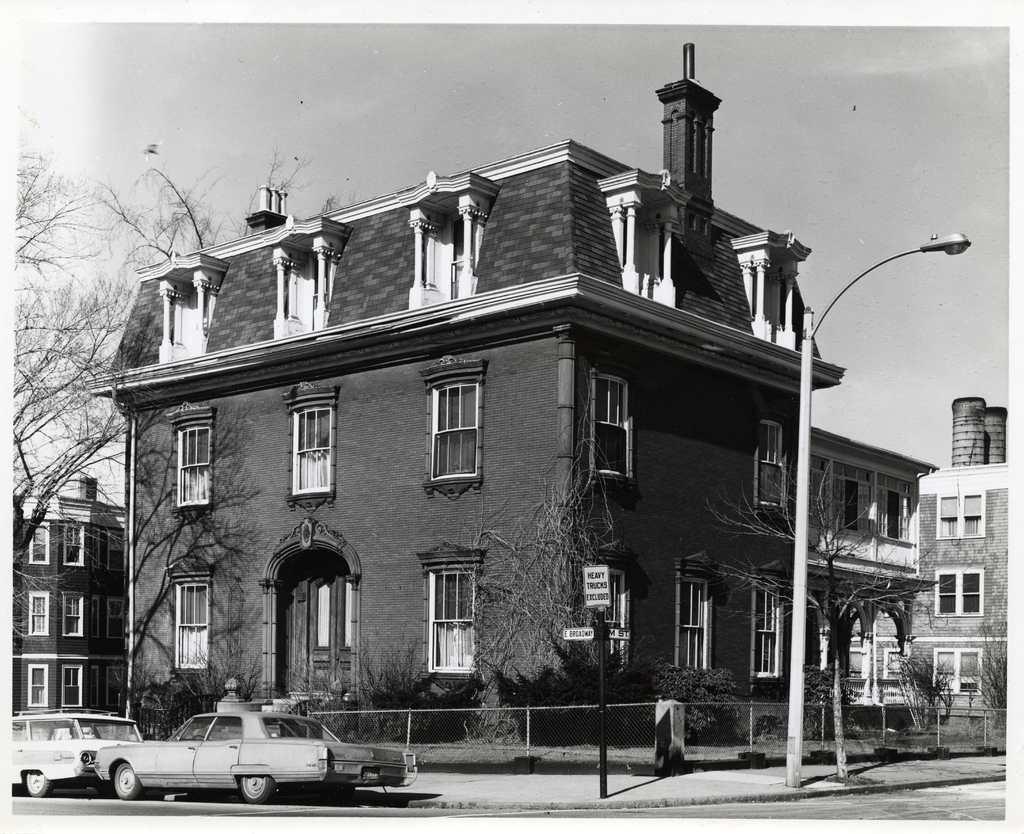Describe this image in one or two sentences. This is a black and white picture. I can see vehicles on the road, fence, poles, boards, buildings, plants, trees, and in the background there is the sky. 